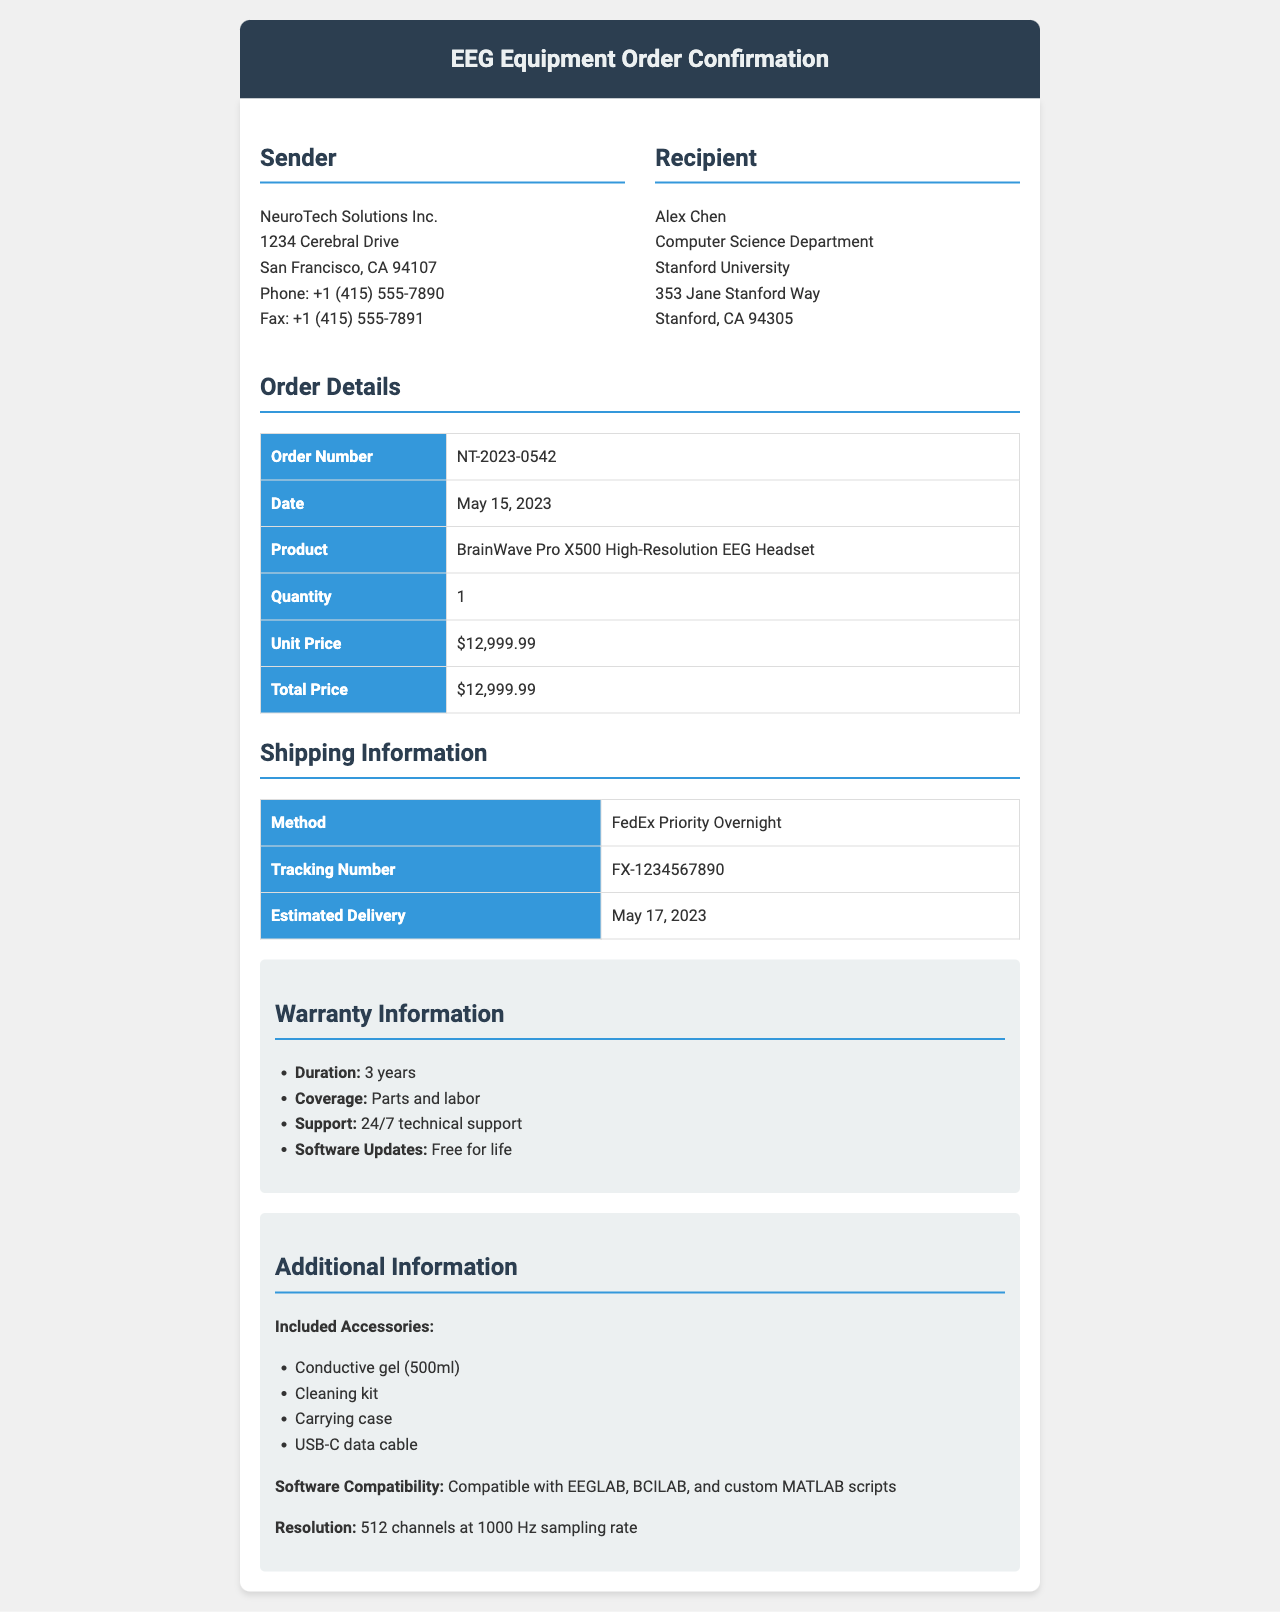What is the order number? The order number is explicitly stated in the document under Order Details as NT-2023-0542.
Answer: NT-2023-0542 Who is the sender of the fax? The sender's information is provided in the document, clearly stating NeuroTech Solutions Inc. as the sender.
Answer: NeuroTech Solutions Inc What is the quantity of EEG headsets ordered? The quantity is specified in the Order Details section of the document, where it states the quantity as 1.
Answer: 1 What is the estimated delivery date? The estimated delivery date is mentioned in the Shipping Information section, listed as May 17, 2023.
Answer: May 17, 2023 What is the warranty duration for the headset? The warranty duration is listed as 3 years in the Warranty Information section.
Answer: 3 years What is the total price of the order? The total price is indicated in the Order Details section, which states it as $12,999.99.
Answer: $12,999.99 What is the shipping method used? The shipping method is specified in the Shipping Information section as FedEx Priority Overnight.
Answer: FedEx Priority Overnight Which included accessory is for cleaning? The included accessories are listed, and the cleaning kit is explicitly mentioned as one of them.
Answer: Cleaning kit What software is compatible with the EEG headset? The document outlines the compatible software in the Additional Information section, naming EEGLAB, BCILAB, and custom MATLAB scripts.
Answer: EEGLAB, BCILAB, and custom MATLAB scripts 